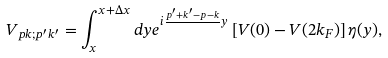Convert formula to latex. <formula><loc_0><loc_0><loc_500><loc_500>V _ { p k ; p ^ { \prime } k ^ { \prime } } = \int _ { x } ^ { x + \Delta x } d y e ^ { i \frac { p ^ { \prime } + k ^ { \prime } - p - k } { } y } \left [ V ( 0 ) - V ( 2 k _ { F } ) \right ] \eta ( y ) ,</formula> 